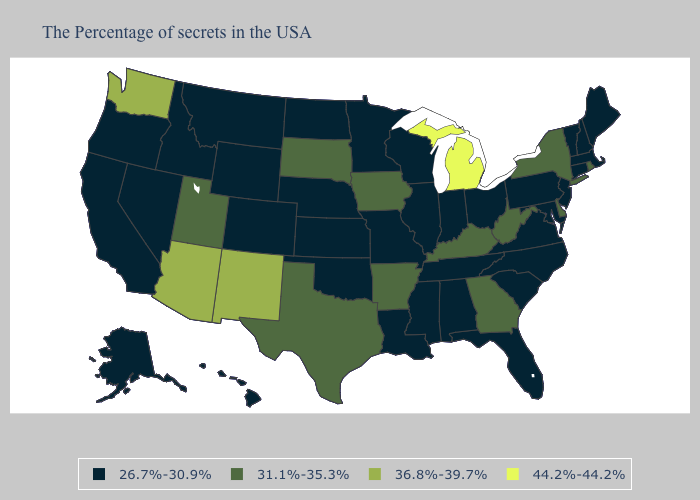What is the value of Washington?
Be succinct. 36.8%-39.7%. Name the states that have a value in the range 44.2%-44.2%?
Be succinct. Michigan. Which states have the lowest value in the USA?
Short answer required. Maine, Massachusetts, New Hampshire, Vermont, Connecticut, New Jersey, Maryland, Pennsylvania, Virginia, North Carolina, South Carolina, Ohio, Florida, Indiana, Alabama, Tennessee, Wisconsin, Illinois, Mississippi, Louisiana, Missouri, Minnesota, Kansas, Nebraska, Oklahoma, North Dakota, Wyoming, Colorado, Montana, Idaho, Nevada, California, Oregon, Alaska, Hawaii. Does Michigan have the highest value in the USA?
Answer briefly. Yes. Name the states that have a value in the range 36.8%-39.7%?
Write a very short answer. New Mexico, Arizona, Washington. Name the states that have a value in the range 44.2%-44.2%?
Concise answer only. Michigan. Does Michigan have the highest value in the MidWest?
Answer briefly. Yes. Which states have the lowest value in the Northeast?
Concise answer only. Maine, Massachusetts, New Hampshire, Vermont, Connecticut, New Jersey, Pennsylvania. Name the states that have a value in the range 31.1%-35.3%?
Give a very brief answer. Rhode Island, New York, Delaware, West Virginia, Georgia, Kentucky, Arkansas, Iowa, Texas, South Dakota, Utah. How many symbols are there in the legend?
Short answer required. 4. What is the value of Missouri?
Be succinct. 26.7%-30.9%. Among the states that border Nevada , does California have the highest value?
Write a very short answer. No. What is the highest value in the USA?
Write a very short answer. 44.2%-44.2%. Does Oregon have the lowest value in the West?
Answer briefly. Yes. What is the value of New Hampshire?
Give a very brief answer. 26.7%-30.9%. 